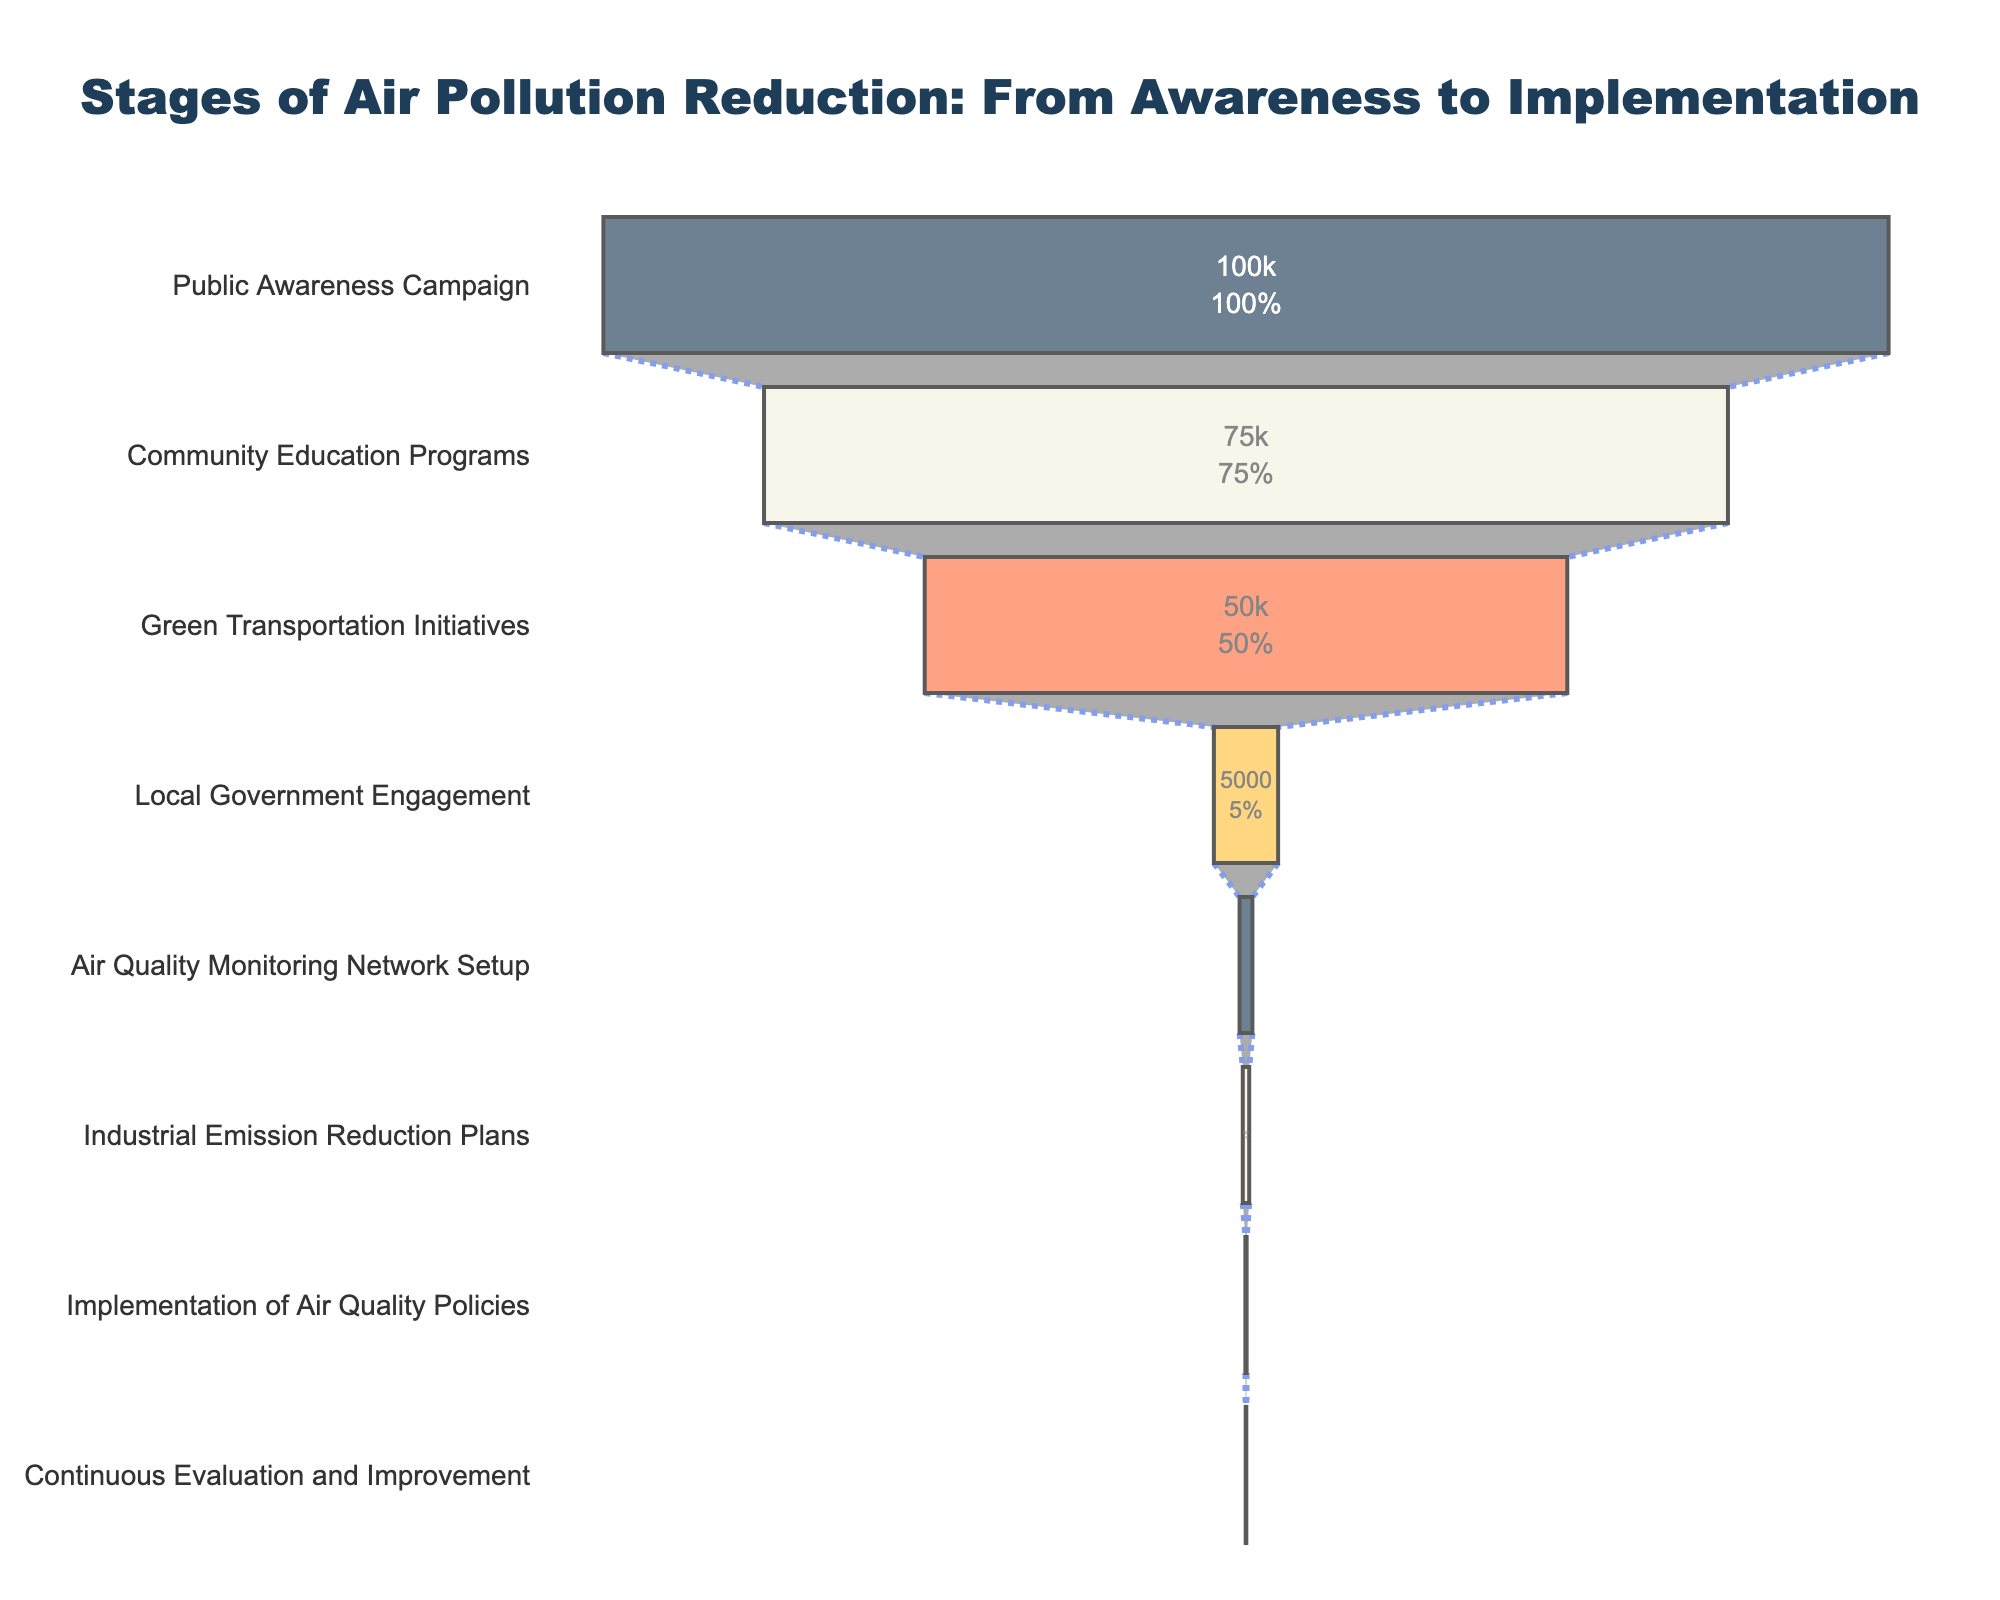What is the title of the funnel chart? The title of the chart is located at the top and it gives an overview of what the figure represents.
Answer: Stages of Air Pollution Reduction: From Awareness to Implementation How many stages are represented in the funnel chart? By counting the number of unique labels on the y-axis, we can determine the number of stages.
Answer: 8 What stage has the highest number of people involved? To find this, look for the stage at the widest part of the funnel, as this represents the largest number of people involved.
Answer: Public Awareness Campaign Which stage has the fewest number of people involved? The narrowest part of the funnel represents the stage with the fewest number of people.
Answer: Continuous Evaluation and Improvement How many more people are involved in the Green Transportation Initiatives compared to Industrial Emission Reduction Plans? The number of people involved in Green Transportation Initiatives is 50,000, and for Industrial Emission Reduction Plans it is 500. The difference can be calculated by subtracting 500 from 50,000.
Answer: 49,500 What percentage of people from the initial total are involved in Local Government Engagement? First, note the number of people involved at the initial stage, which is 100,000. The number of people involved in Local Government Engagement is 5,000. The percentage is calculated as (5,000 / 100,000) * 100.
Answer: 5% Which stages have fewer than 1,000 people involved? By looking at the x-axis values, identify stages with values less than 1,000: Local Government Engagement and Industrial Emission Reduction Plans.
Answer: Local Government Engagement, Industrial Emission Reduction Plans What is the combined total number of people involved in the Community Education Programs and Green Transportation Initiatives? The number of people involved in Community Education Programs is 75,000 and in Green Transportation Initiatives it is 50,000. Summing these gives the total.
Answer: 125,000 How many stages show a reduction in the number of people involved by more than 90% from any earlier stage? Compare the number of people involved in each stage to previous stages. For example, Local Government Engagement (5,000) is a 93.33% reduction from Community Education Programs (75,000). Similar comparisons show significant reductions.
Answer: 4 